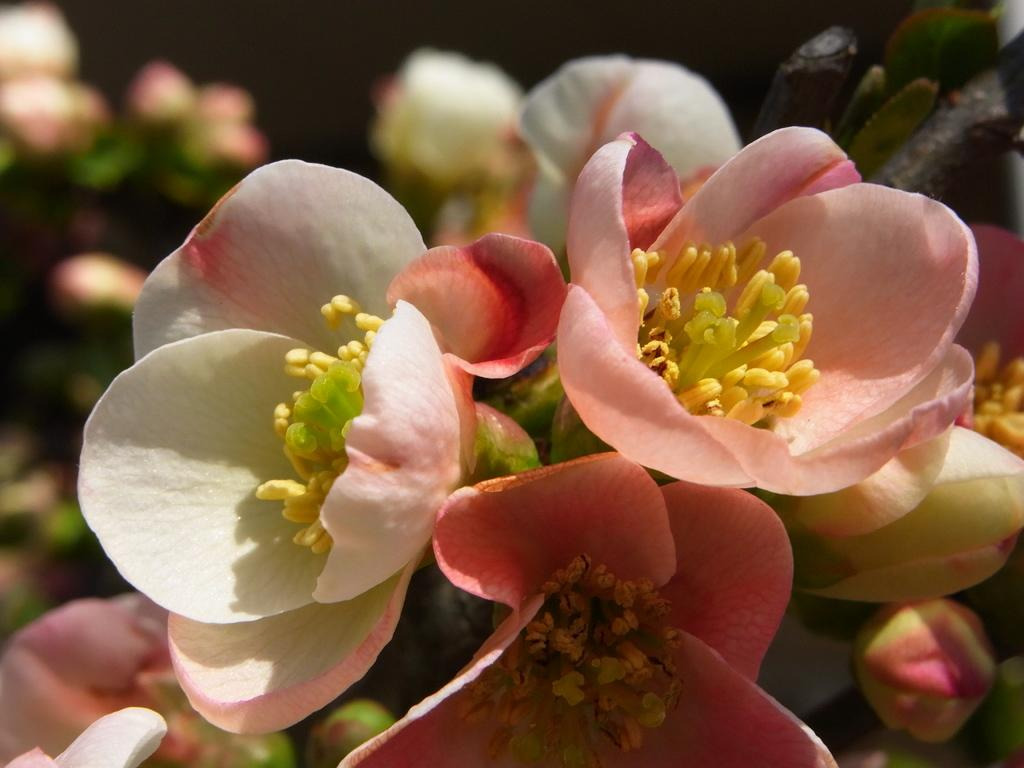What type of plants can be seen in the image? The image contains flowers. Are there any unopened flowers in the image? Yes, there are buds in the image. What else can be seen in the image besides flowers? The image contains stems. How would you describe the background of the image? The background of the image is blurred. What other elements can be seen in the background of the image? There are flowers and leaves in the background of the image. What decision did the queen make regarding the store in the image? There is no queen, store, or decision present in the image; it features flowers, buds, stems, and a blurred background. 